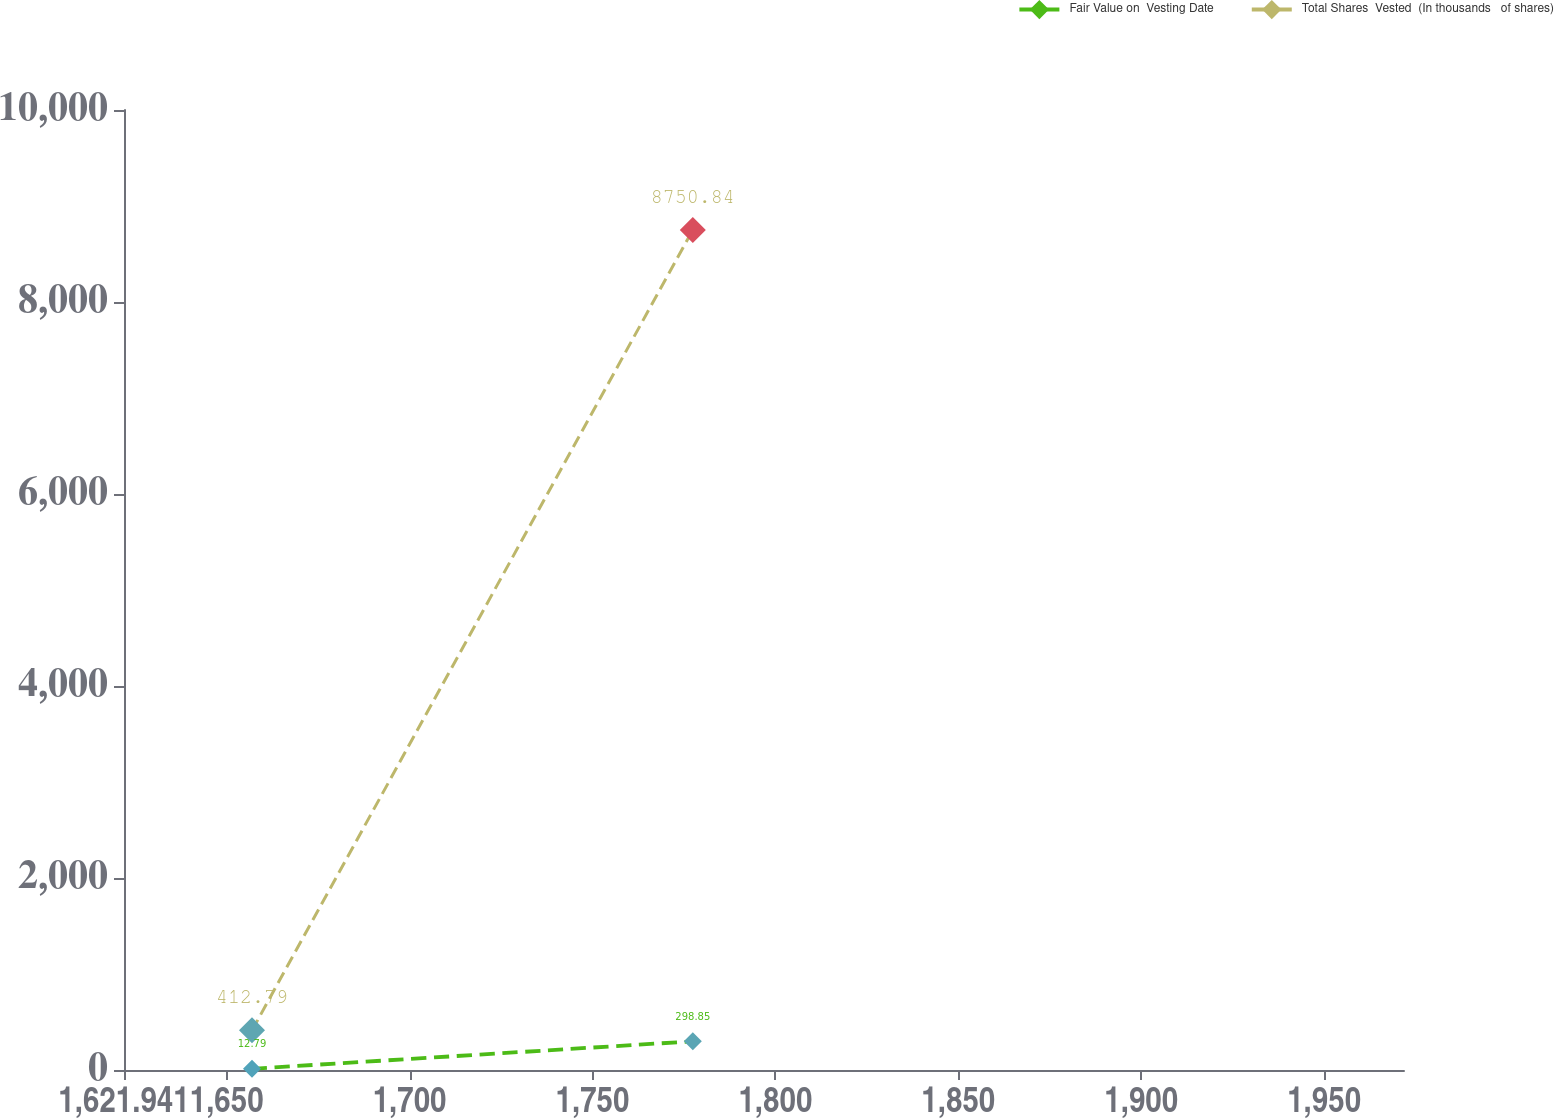Convert chart to OTSL. <chart><loc_0><loc_0><loc_500><loc_500><line_chart><ecel><fcel>Fair Value on  Vesting Date<fcel>Total Shares  Vested  (In thousands   of shares)<nl><fcel>1656.93<fcel>12.79<fcel>412.79<nl><fcel>1777.43<fcel>298.85<fcel>8750.84<nl><fcel>2006.82<fcel>249.11<fcel>7035.69<nl></chart> 